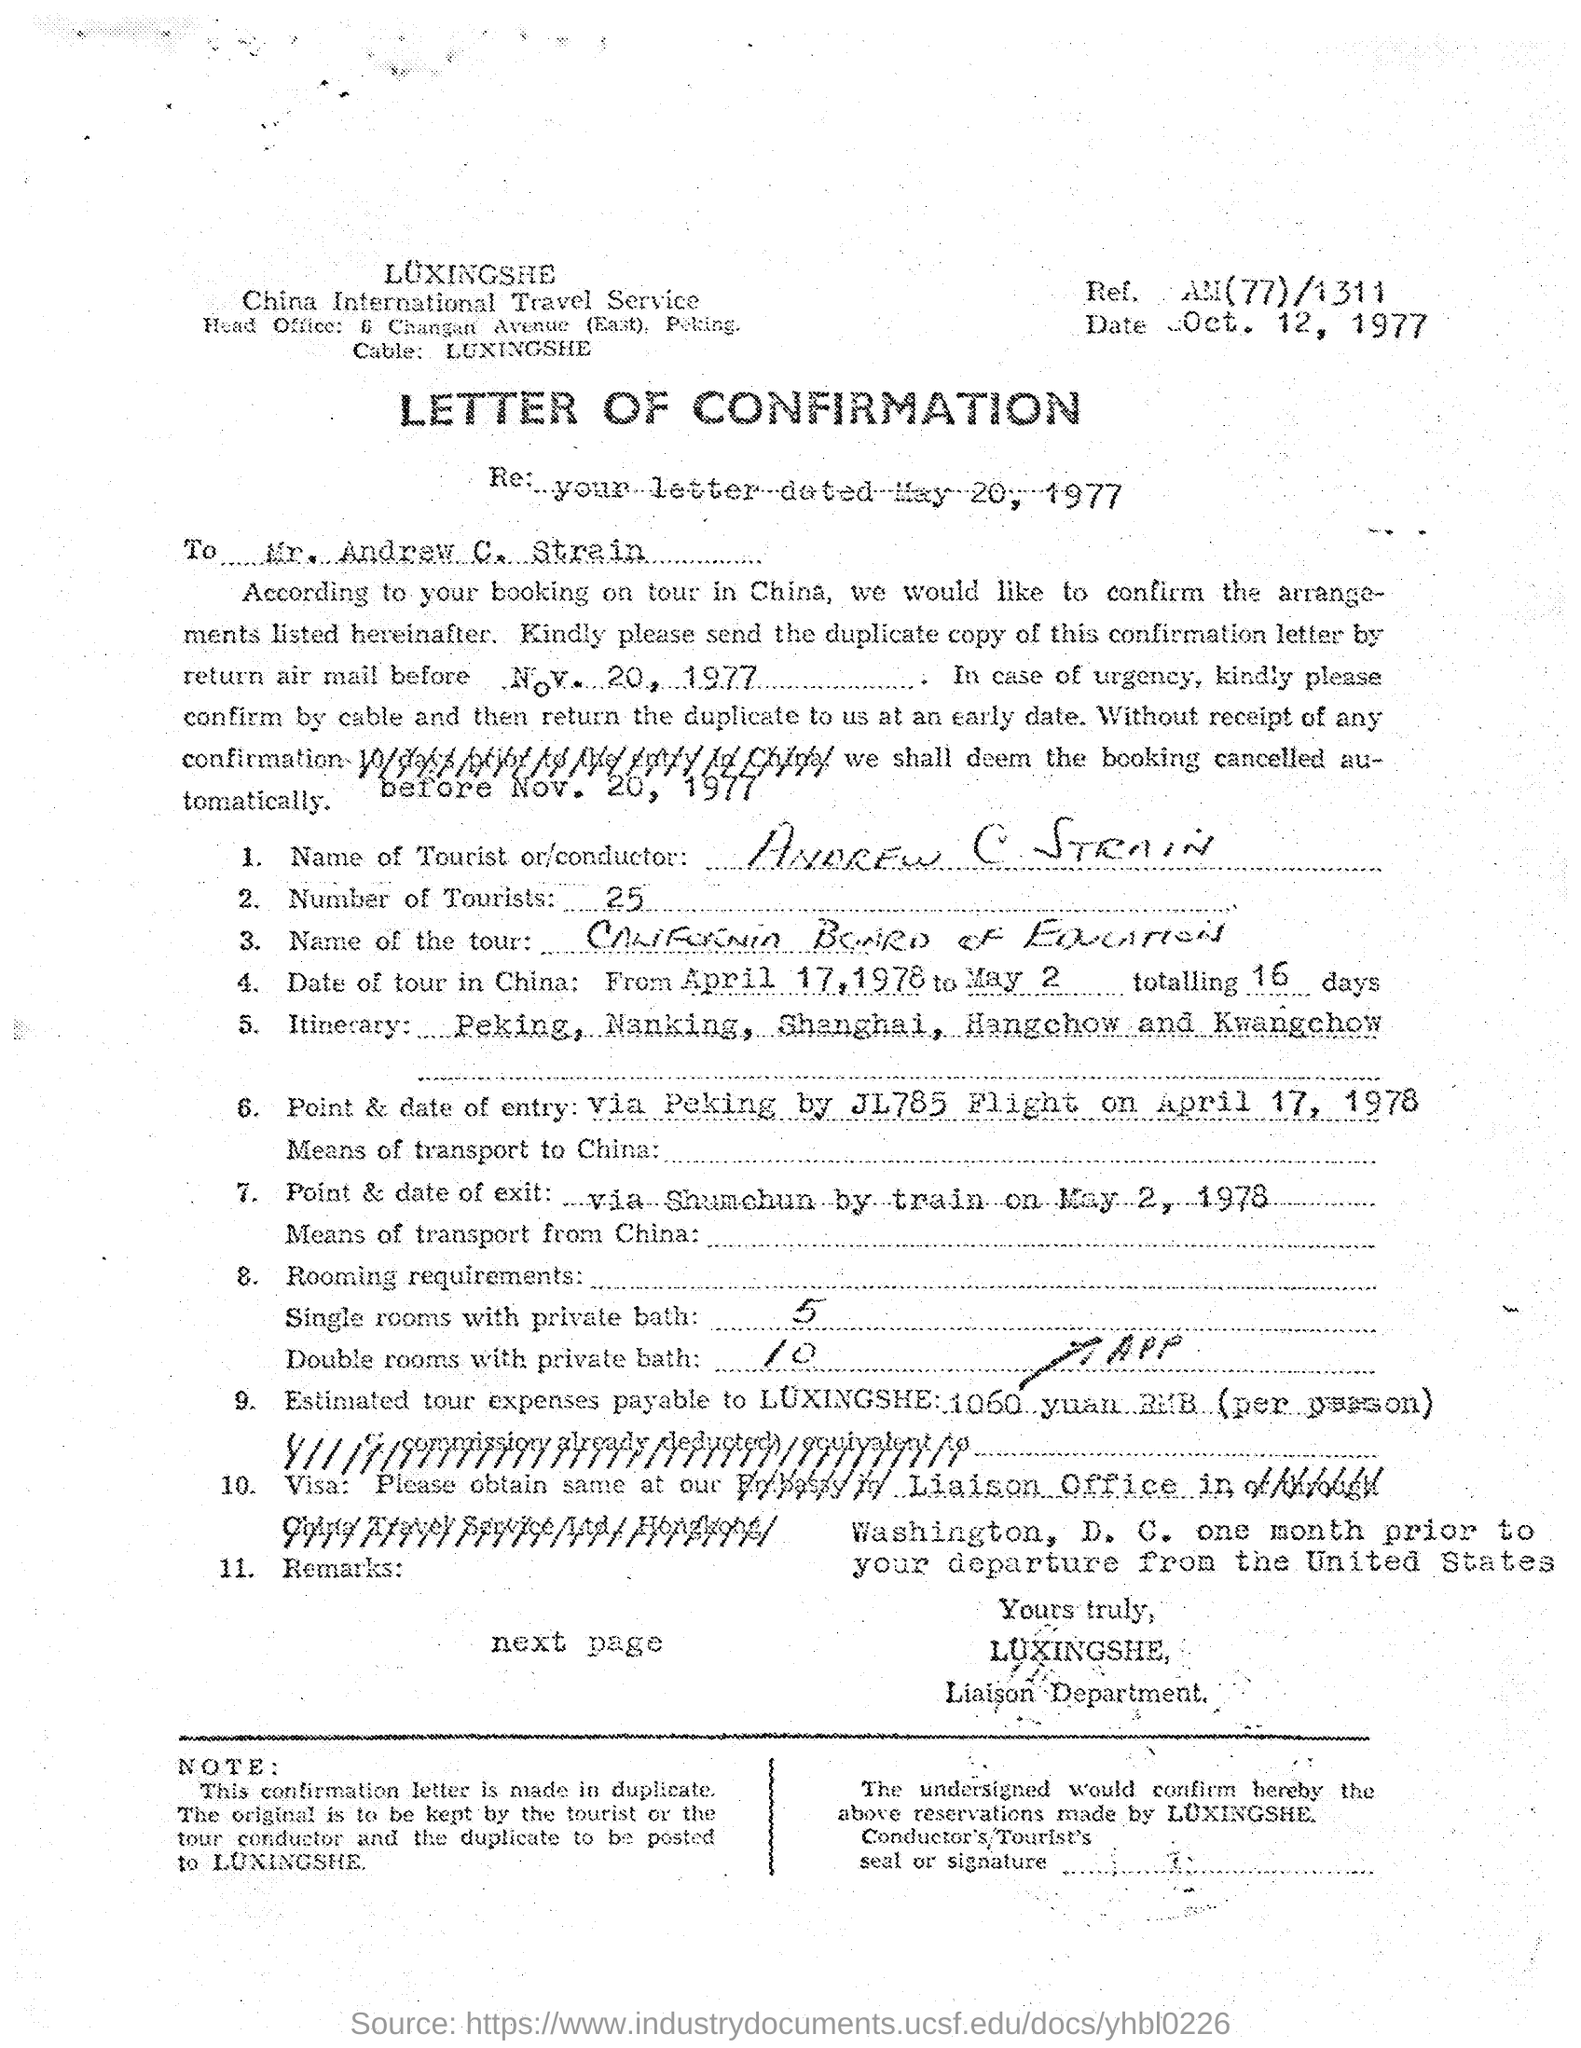Outline some significant characteristics in this image. According to the document, there are approximately 25 tourists. The addressee of this letter is Mr. Andrew C. Strain. This document is a letter of confirmation. Andrew C. Strain is the tourist mentioned in the letter. The date mentioned in the letterhead is October 12, 1977. 